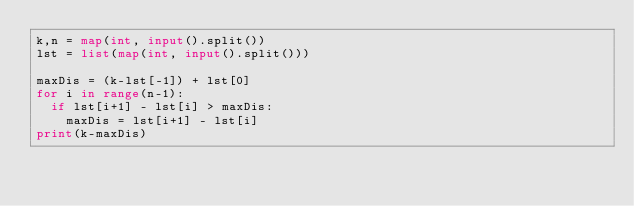<code> <loc_0><loc_0><loc_500><loc_500><_Python_>k,n = map(int, input().split())
lst = list(map(int, input().split()))

maxDis = (k-lst[-1]) + lst[0]
for i in range(n-1):
  if lst[i+1] - lst[i] > maxDis:
    maxDis = lst[i+1] - lst[i]
print(k-maxDis)</code> 